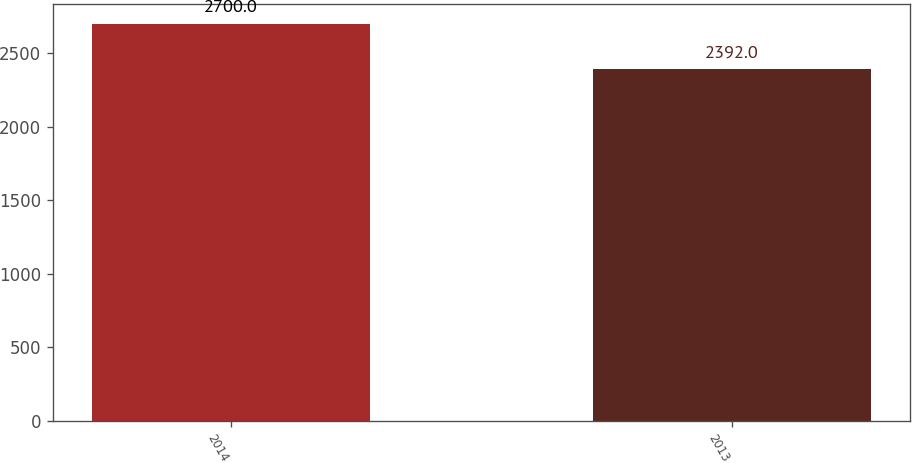Convert chart to OTSL. <chart><loc_0><loc_0><loc_500><loc_500><bar_chart><fcel>2014<fcel>2013<nl><fcel>2700<fcel>2392<nl></chart> 